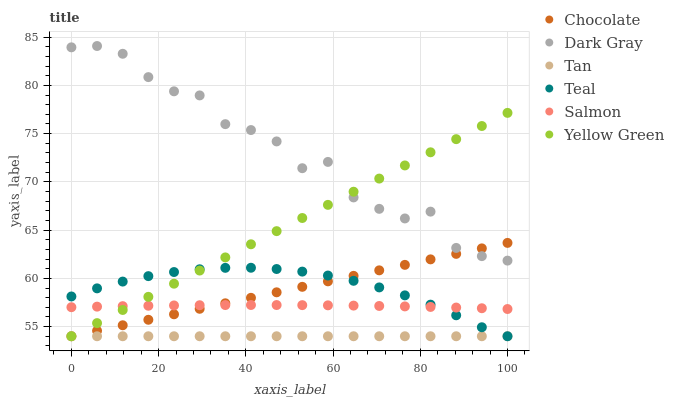Does Tan have the minimum area under the curve?
Answer yes or no. Yes. Does Dark Gray have the maximum area under the curve?
Answer yes or no. Yes. Does Salmon have the minimum area under the curve?
Answer yes or no. No. Does Salmon have the maximum area under the curve?
Answer yes or no. No. Is Tan the smoothest?
Answer yes or no. Yes. Is Dark Gray the roughest?
Answer yes or no. Yes. Is Salmon the smoothest?
Answer yes or no. No. Is Salmon the roughest?
Answer yes or no. No. Does Yellow Green have the lowest value?
Answer yes or no. Yes. Does Salmon have the lowest value?
Answer yes or no. No. Does Dark Gray have the highest value?
Answer yes or no. Yes. Does Salmon have the highest value?
Answer yes or no. No. Is Teal less than Dark Gray?
Answer yes or no. Yes. Is Salmon greater than Tan?
Answer yes or no. Yes. Does Yellow Green intersect Salmon?
Answer yes or no. Yes. Is Yellow Green less than Salmon?
Answer yes or no. No. Is Yellow Green greater than Salmon?
Answer yes or no. No. Does Teal intersect Dark Gray?
Answer yes or no. No. 